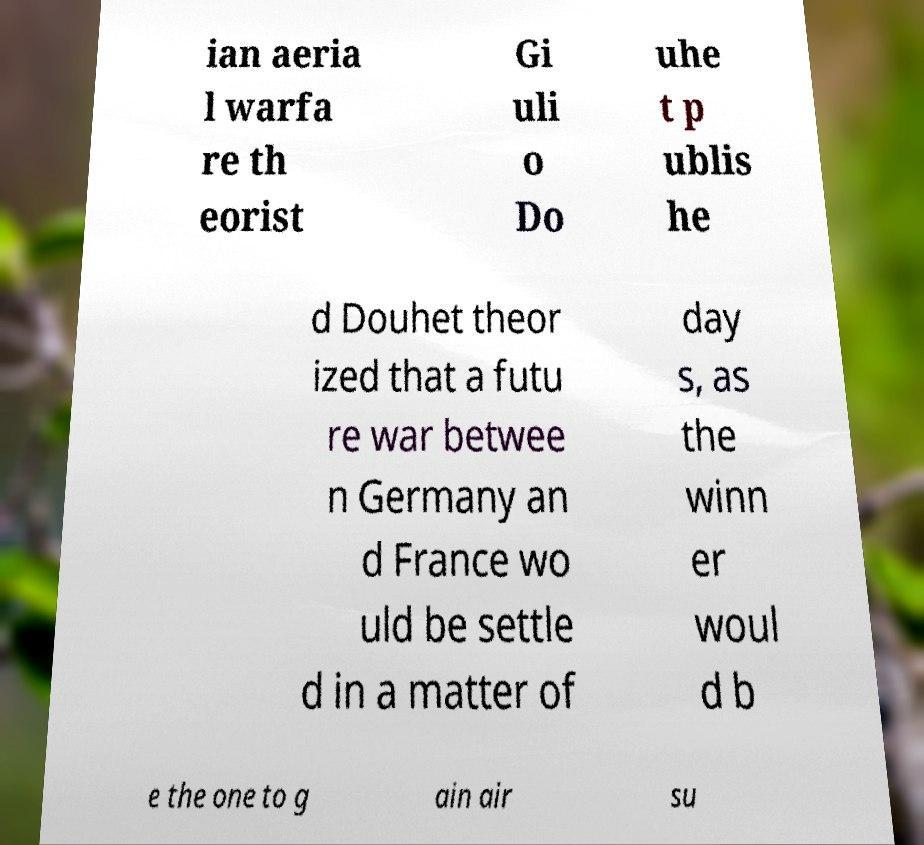Please identify and transcribe the text found in this image. ian aeria l warfa re th eorist Gi uli o Do uhe t p ublis he d Douhet theor ized that a futu re war betwee n Germany an d France wo uld be settle d in a matter of day s, as the winn er woul d b e the one to g ain air su 